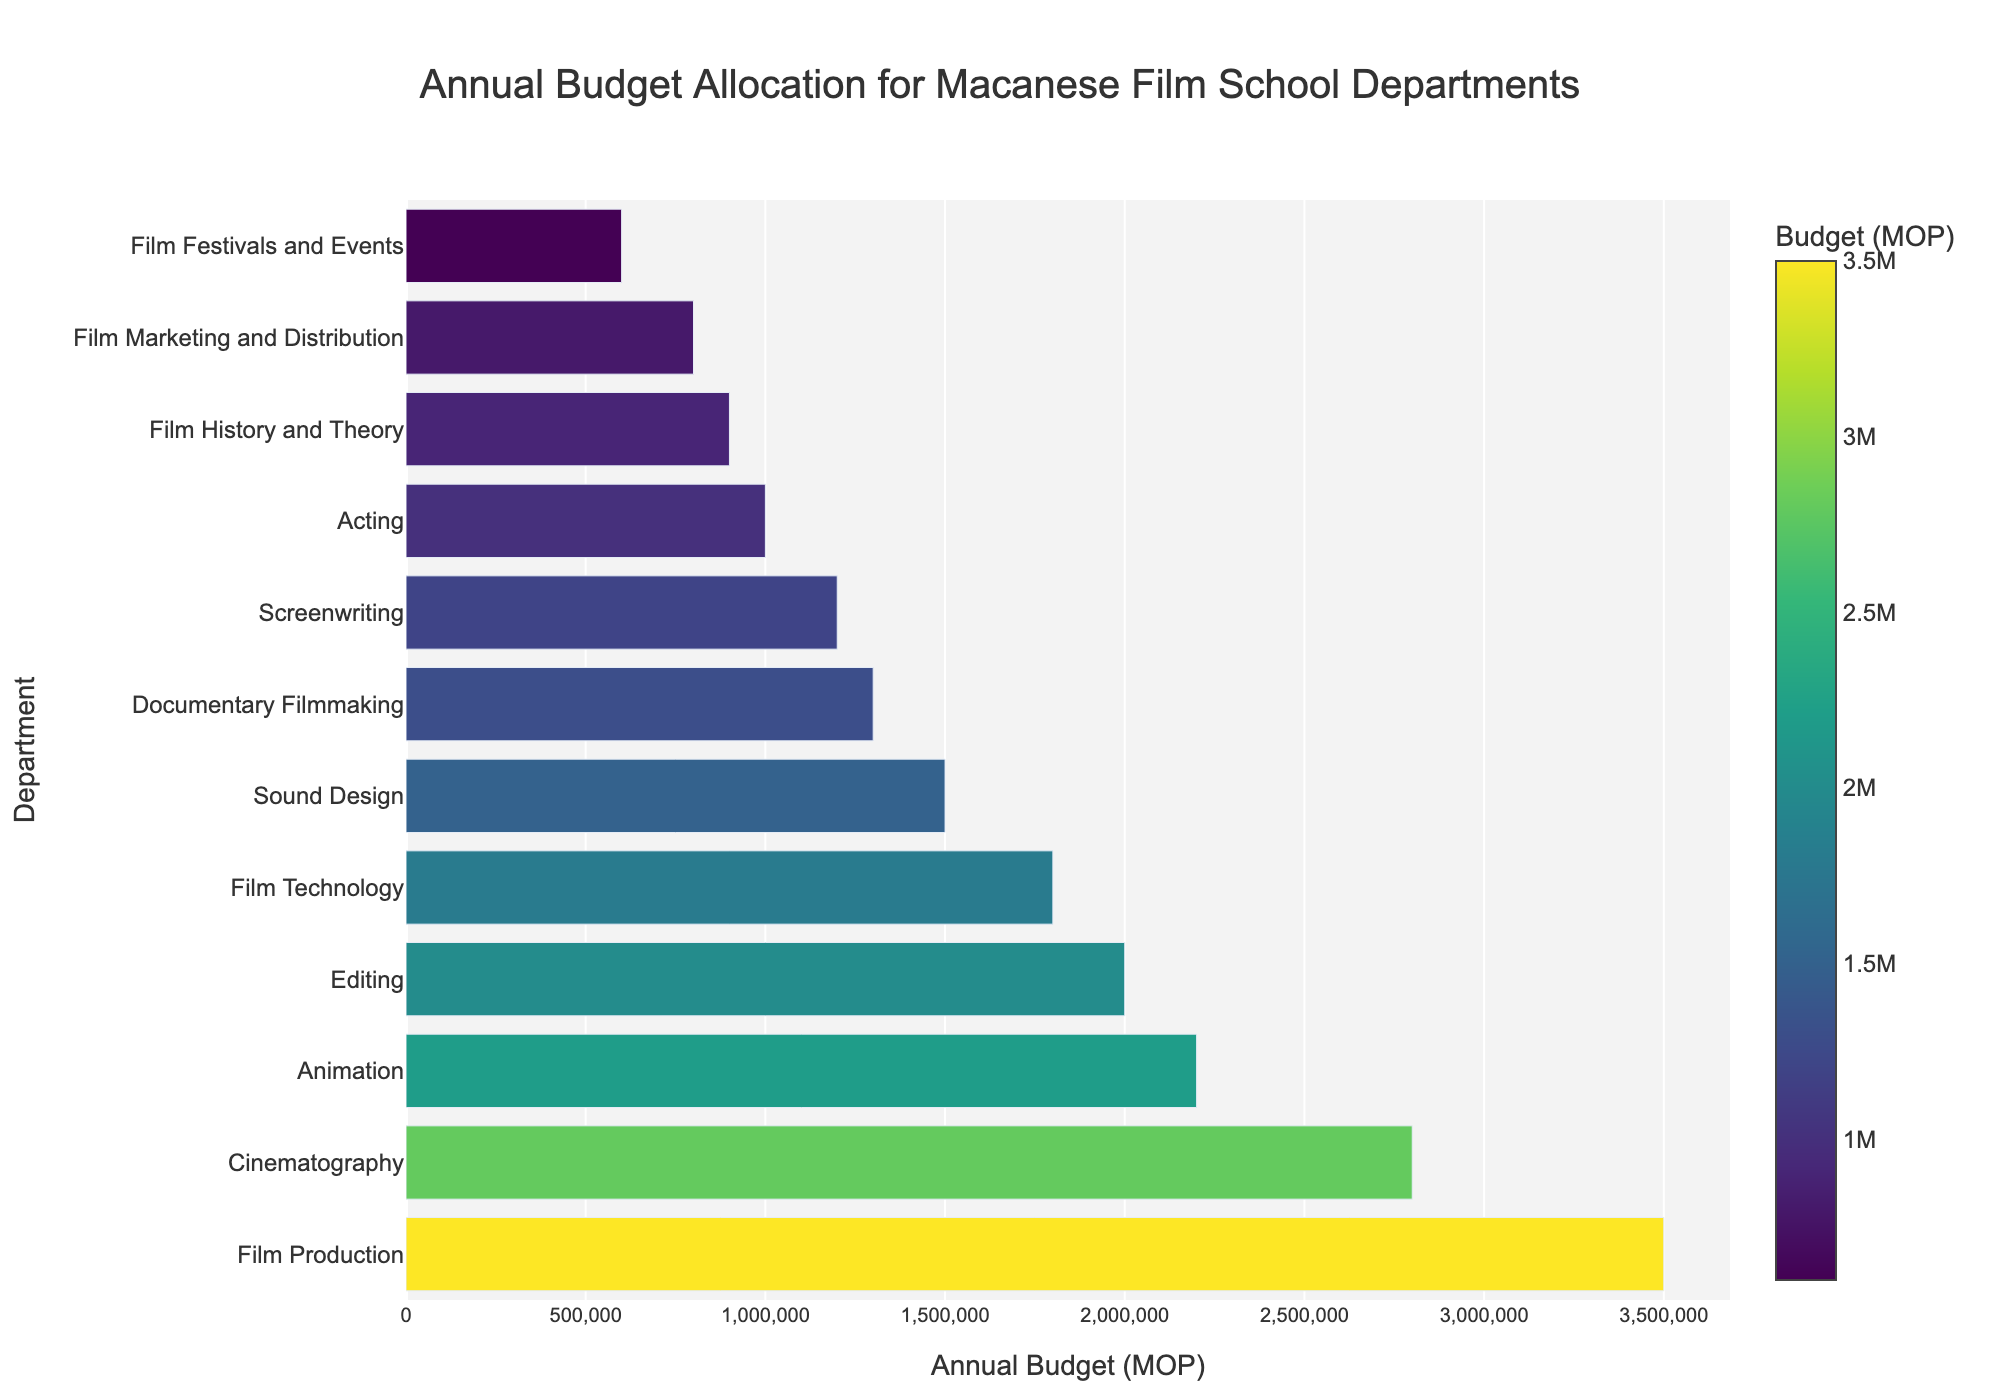Which department has the highest annual budget? The highest annual budget can be seen by the length of the bar. The longest bar represents "Film Production".
Answer: Film Production Which department has the lowest annual budget? The lowest annual budget can be determined by the shortest bar. The shortest bar represents "Film Festivals and Events".
Answer: Film Festivals and Events What is the combined budget of the Screenwriting and Sound Design departments? To find the combined budget, add the annual budgets of both departments. Screenwriting has 1200000 MOP and Sound Design has 1500000 MOP. The total is 1200000 + 1500000.
Answer: 2700000 MOP By how much does the Film Production budget exceed the Editing budget? Film Production has a budget of 3500000 MOP, and Editing has a budget of 2000000 MOP. Subtract the Editing budget from the Film Production budget (3500000 - 2000000).
Answer: 1500000 MOP Which two departments have the closest budget amounts? By comparing the lengths of the bars, we see that "Screenwriting" and "Documentary Filmmaking" have very similar lengths corresponding to 1200000 MOP and 1300000 MOP respectively. The difference is only 100000 MOP.
Answer: Screenwriting and Documentary Filmmaking What is the total annual budget for all departments combined? Add all the annual budgets of each department: 3500000 + 1200000 + 900000 + 2800000 + 1500000 + 2000000 + 1000000 + 2200000 + 1300000 + 800000 + 1800000 + 600000.
Answer: 19600000 MOP How many departments have an annual budget of over 2 million MOP? By counting the bars that extend beyond the 2 million MOP mark, we identify five bars: Film Production, Cinematography, Editing, Animation, and Film Technology.
Answer: 5 Which equipment-focused department (Cinematography and Film Technology) has a higher annual budget? Compare the budgets of Cinematography (2800000 MOP) and Film Technology (1800000 MOP).
Answer: Cinematography What is the average annual budget for all departments? Sum all the annual budgets and divide by the number of departments: \( \frac{3500000 + 1200000 + 900000 + 2800000 + 1500000 + 2000000 + 1000000 + 2200000 + 1300000 + 800000 + 1800000 + 600000}{12} \).
Answer: 1633333 MOP What is the difference between the highest and lowest department budgets? Subtract the lowest budget (Film Festivals and Events, 600000 MOP) from the highest budget (Film Production, 3500000 MOP): 3500000 - 600000.
Answer: 2900000 MOP 